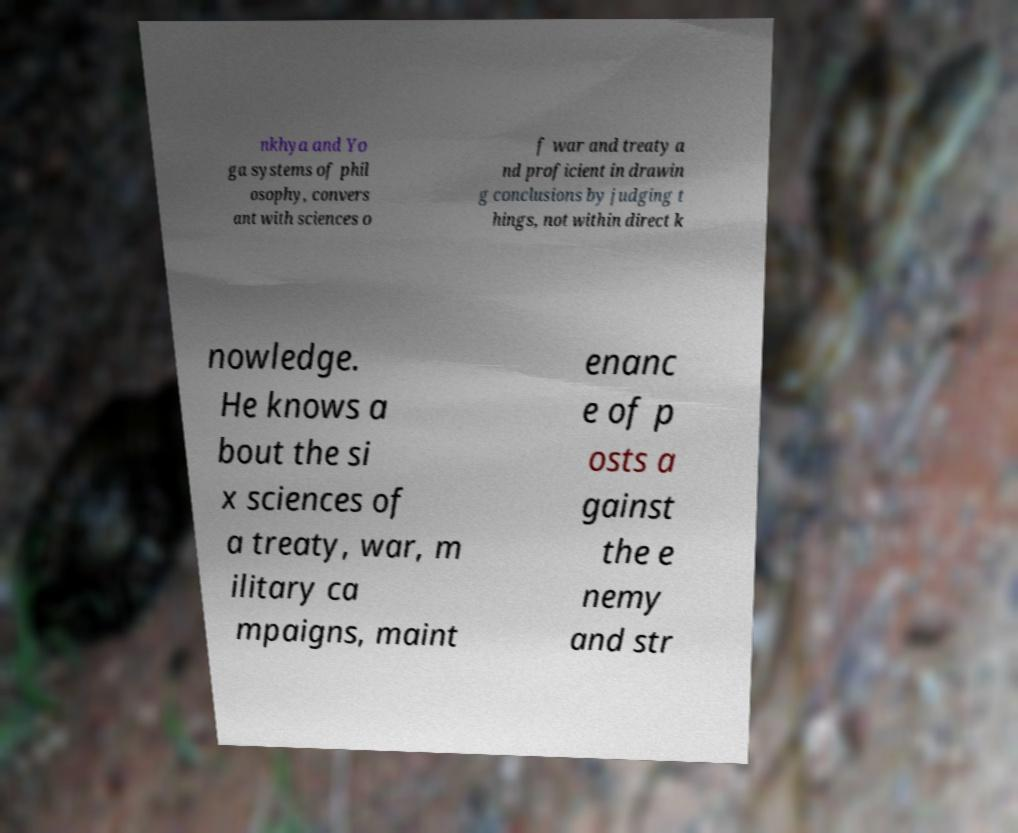For documentation purposes, I need the text within this image transcribed. Could you provide that? nkhya and Yo ga systems of phil osophy, convers ant with sciences o f war and treaty a nd proficient in drawin g conclusions by judging t hings, not within direct k nowledge. He knows a bout the si x sciences of a treaty, war, m ilitary ca mpaigns, maint enanc e of p osts a gainst the e nemy and str 